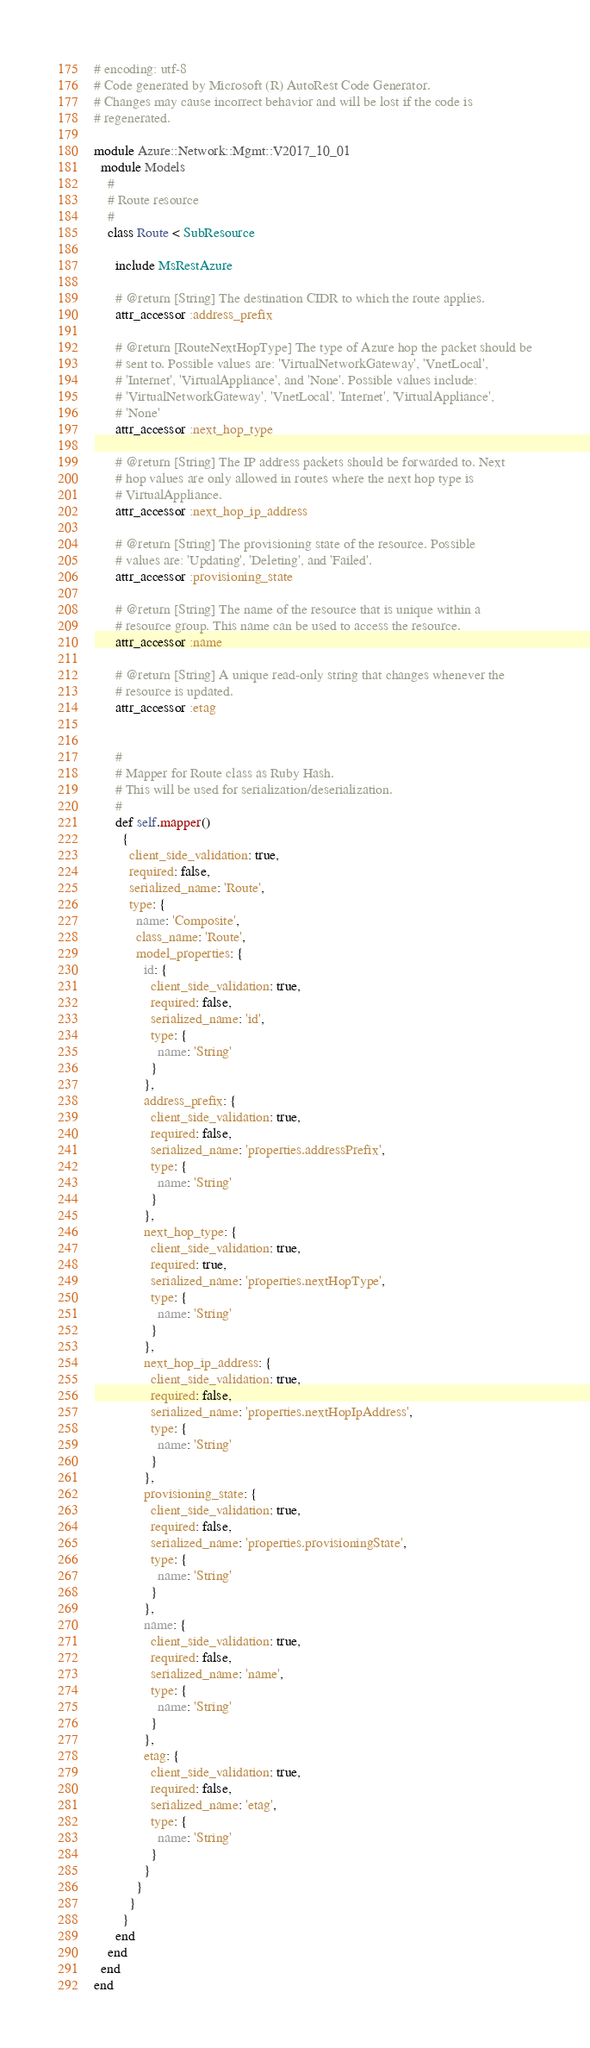<code> <loc_0><loc_0><loc_500><loc_500><_Ruby_># encoding: utf-8
# Code generated by Microsoft (R) AutoRest Code Generator.
# Changes may cause incorrect behavior and will be lost if the code is
# regenerated.

module Azure::Network::Mgmt::V2017_10_01
  module Models
    #
    # Route resource
    #
    class Route < SubResource

      include MsRestAzure

      # @return [String] The destination CIDR to which the route applies.
      attr_accessor :address_prefix

      # @return [RouteNextHopType] The type of Azure hop the packet should be
      # sent to. Possible values are: 'VirtualNetworkGateway', 'VnetLocal',
      # 'Internet', 'VirtualAppliance', and 'None'. Possible values include:
      # 'VirtualNetworkGateway', 'VnetLocal', 'Internet', 'VirtualAppliance',
      # 'None'
      attr_accessor :next_hop_type

      # @return [String] The IP address packets should be forwarded to. Next
      # hop values are only allowed in routes where the next hop type is
      # VirtualAppliance.
      attr_accessor :next_hop_ip_address

      # @return [String] The provisioning state of the resource. Possible
      # values are: 'Updating', 'Deleting', and 'Failed'.
      attr_accessor :provisioning_state

      # @return [String] The name of the resource that is unique within a
      # resource group. This name can be used to access the resource.
      attr_accessor :name

      # @return [String] A unique read-only string that changes whenever the
      # resource is updated.
      attr_accessor :etag


      #
      # Mapper for Route class as Ruby Hash.
      # This will be used for serialization/deserialization.
      #
      def self.mapper()
        {
          client_side_validation: true,
          required: false,
          serialized_name: 'Route',
          type: {
            name: 'Composite',
            class_name: 'Route',
            model_properties: {
              id: {
                client_side_validation: true,
                required: false,
                serialized_name: 'id',
                type: {
                  name: 'String'
                }
              },
              address_prefix: {
                client_side_validation: true,
                required: false,
                serialized_name: 'properties.addressPrefix',
                type: {
                  name: 'String'
                }
              },
              next_hop_type: {
                client_side_validation: true,
                required: true,
                serialized_name: 'properties.nextHopType',
                type: {
                  name: 'String'
                }
              },
              next_hop_ip_address: {
                client_side_validation: true,
                required: false,
                serialized_name: 'properties.nextHopIpAddress',
                type: {
                  name: 'String'
                }
              },
              provisioning_state: {
                client_side_validation: true,
                required: false,
                serialized_name: 'properties.provisioningState',
                type: {
                  name: 'String'
                }
              },
              name: {
                client_side_validation: true,
                required: false,
                serialized_name: 'name',
                type: {
                  name: 'String'
                }
              },
              etag: {
                client_side_validation: true,
                required: false,
                serialized_name: 'etag',
                type: {
                  name: 'String'
                }
              }
            }
          }
        }
      end
    end
  end
end
</code> 